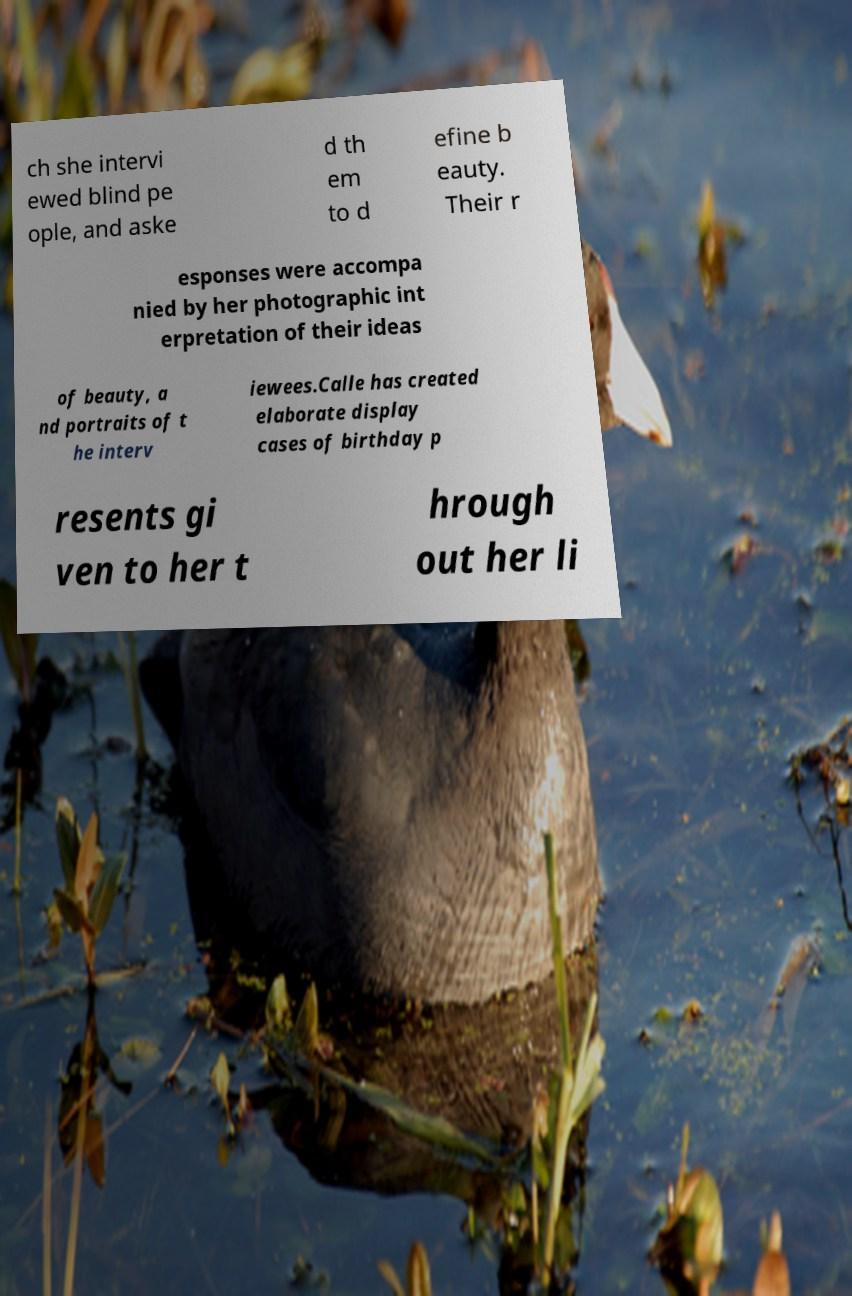Can you accurately transcribe the text from the provided image for me? ch she intervi ewed blind pe ople, and aske d th em to d efine b eauty. Their r esponses were accompa nied by her photographic int erpretation of their ideas of beauty, a nd portraits of t he interv iewees.Calle has created elaborate display cases of birthday p resents gi ven to her t hrough out her li 